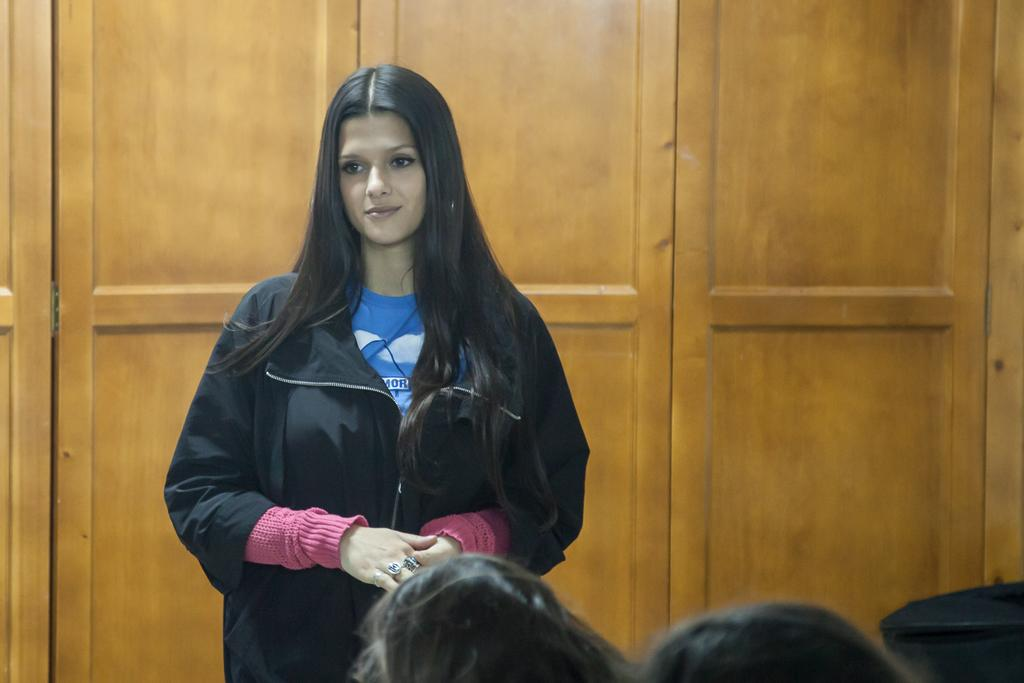How many people are in the image? There are people in the image, but the exact number is not specified. What is the position of one of the people in the image? One person is standing in the image. What type of objects can be seen in the background that resemble doors? There are wooden objects in the background that resemble doors. Are there any fairies visible in the image? There is no mention of fairies in the image, so we cannot confirm their presence. How many cats can be seen playing with the wooden objects in the background? There is no mention of cats in the image, so we cannot confirm their presence or the number of cats. 